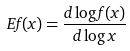Convert formula to latex. <formula><loc_0><loc_0><loc_500><loc_500>E f ( x ) = \frac { d \log f ( x ) } { d \log x }</formula> 